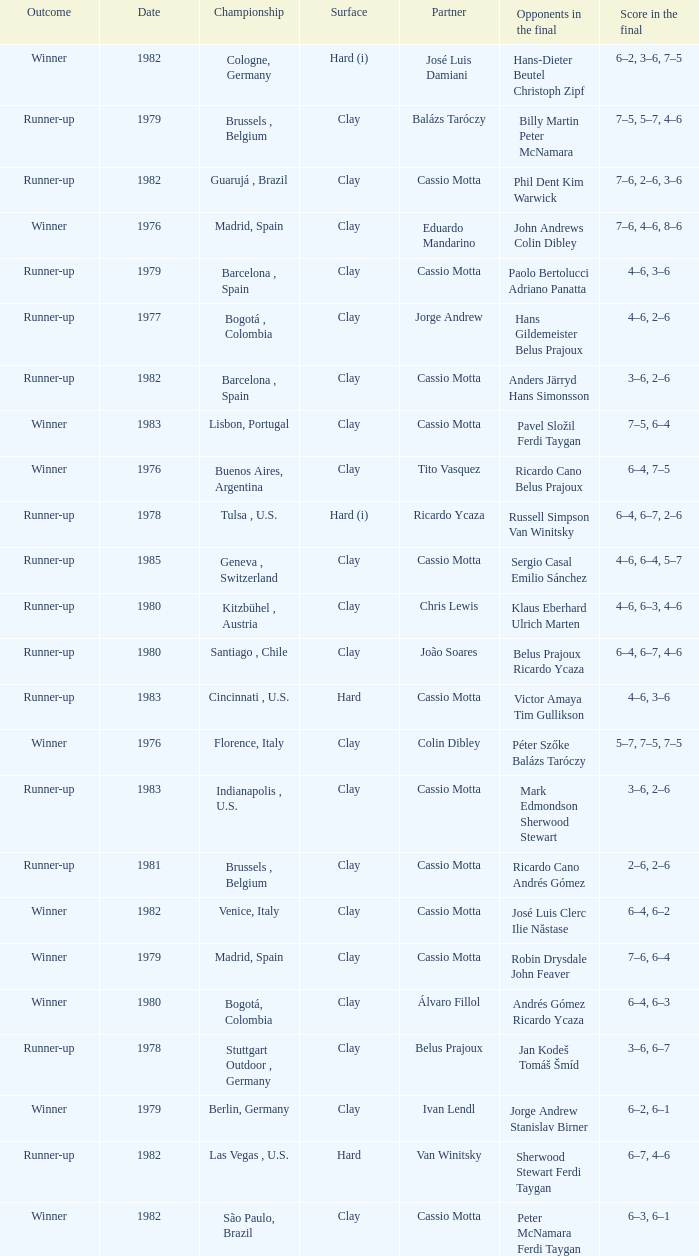What is the outcome on a hard surface, when the score in the final was 4–6, 3–6? Runner-up. 